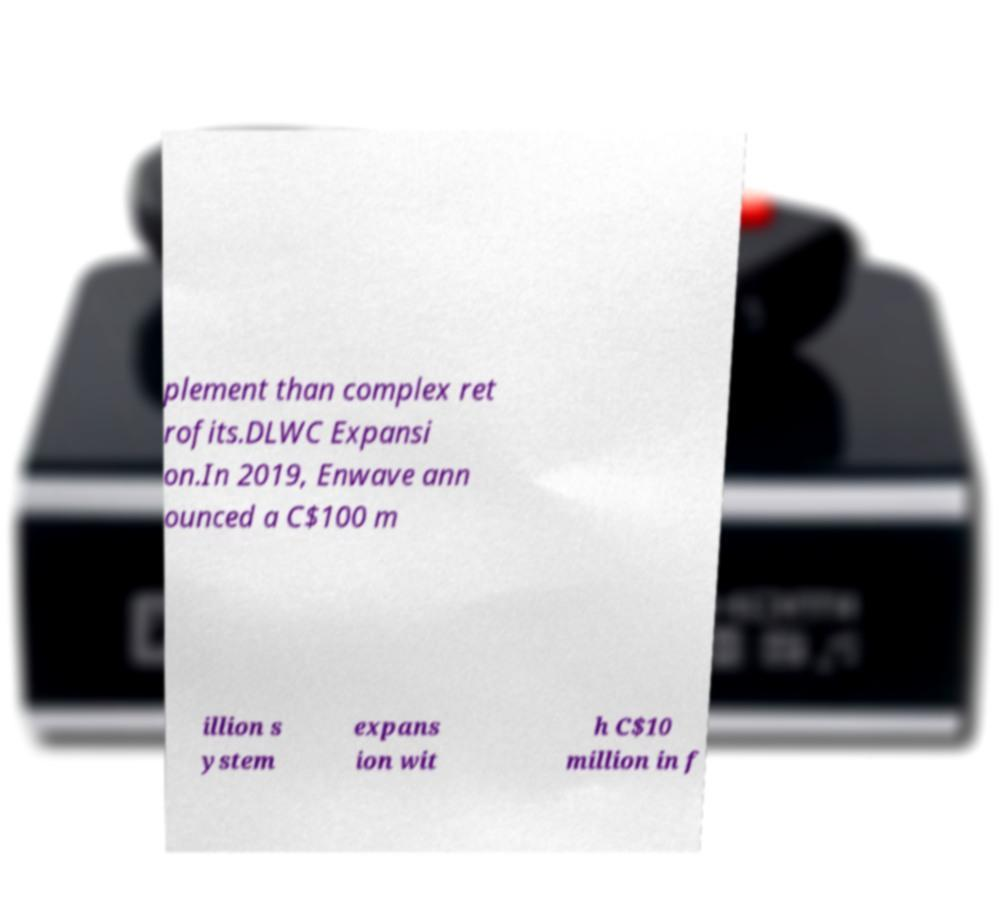Could you extract and type out the text from this image? plement than complex ret rofits.DLWC Expansi on.In 2019, Enwave ann ounced a C$100 m illion s ystem expans ion wit h C$10 million in f 